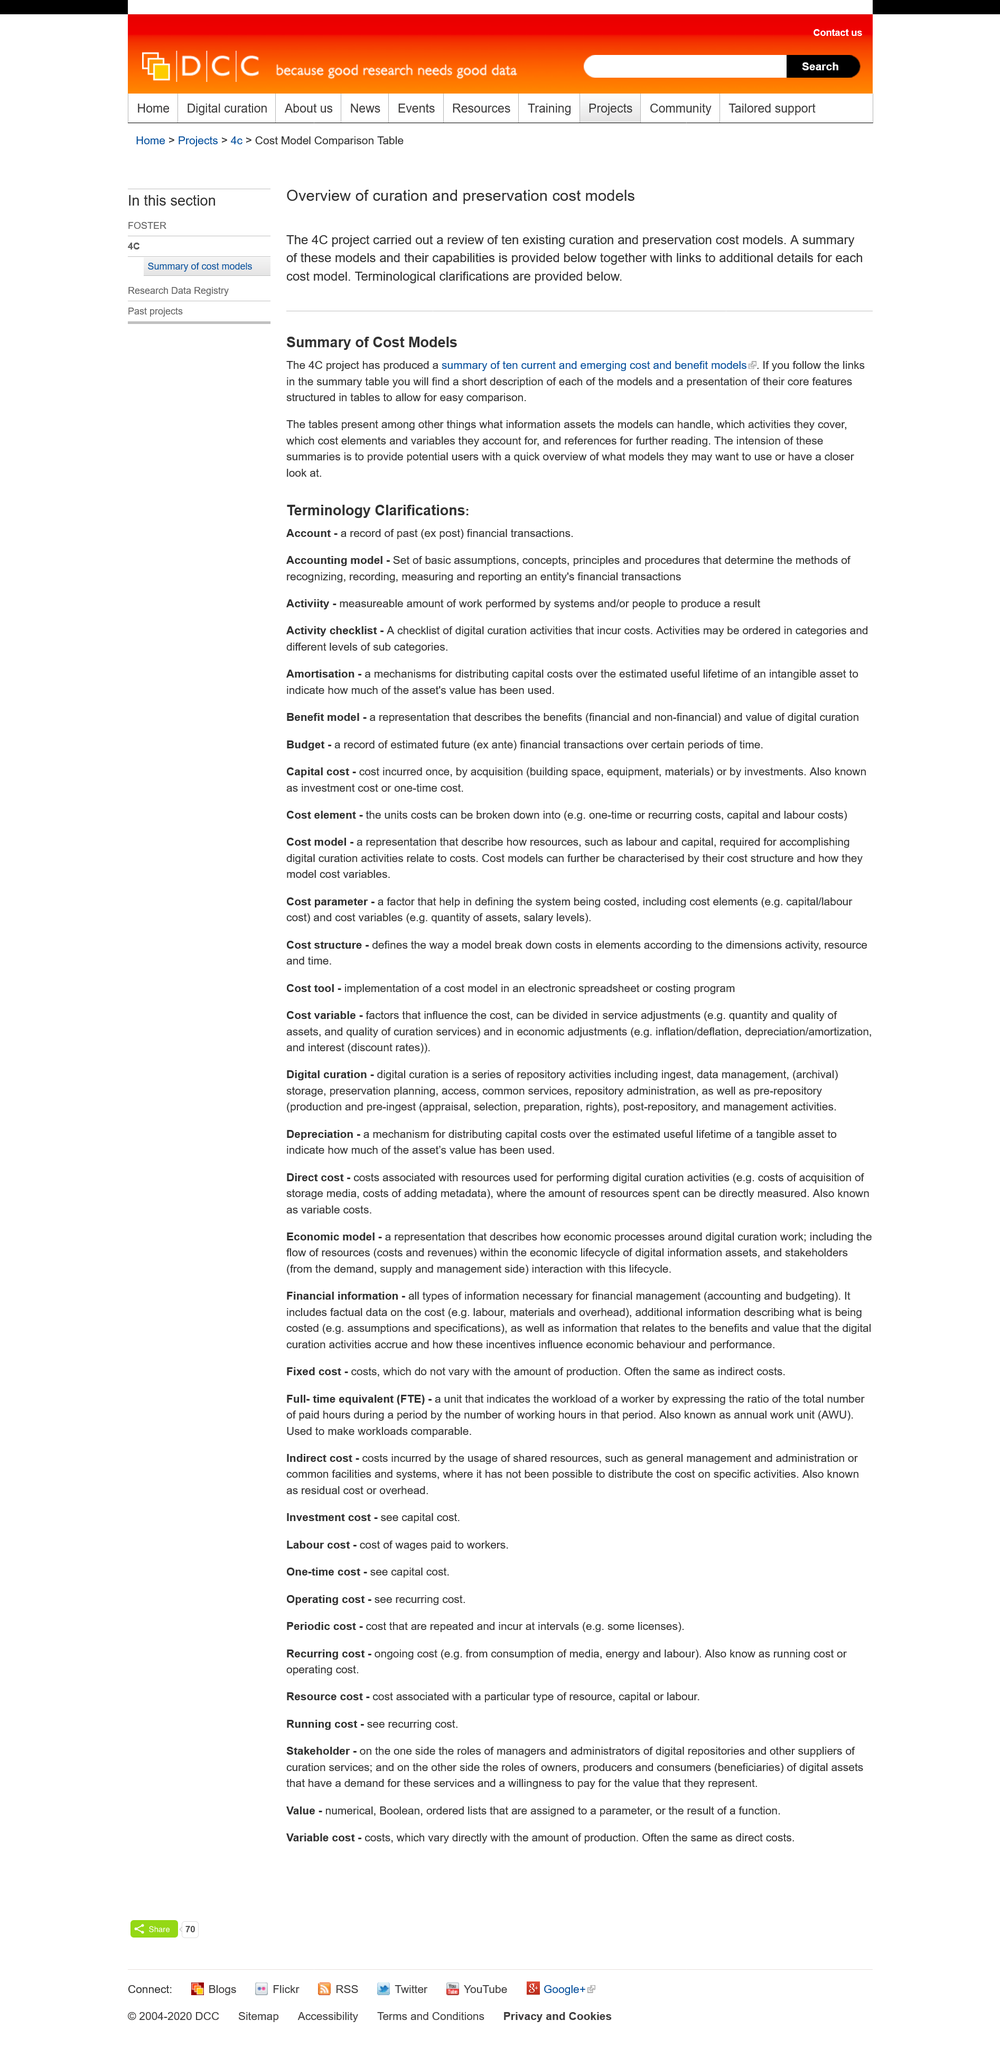Identify some key points in this picture. The summaries of the 4C project aim to provide potential users with a comprehensive overview of the various models available for their consideration. The 4C project has produced a comprehensive summary of ten current and emerging cost and benefit models that have been used or could be used in the context of climate change mitigation and adaptation. These models have been developed and applied in various sectors such as transportation, buildings, and industry. The summary provides a detailed overview of each model, including its strengths, limitations, and applications. Additionally, the project has explored the potential implications and uncertainties associated with the use of these models, highlighting the need for further research and dialogue to inform decision-making processes. The 4C project conducted a review of ten existing curation and preservation cost models as part of its efforts. 